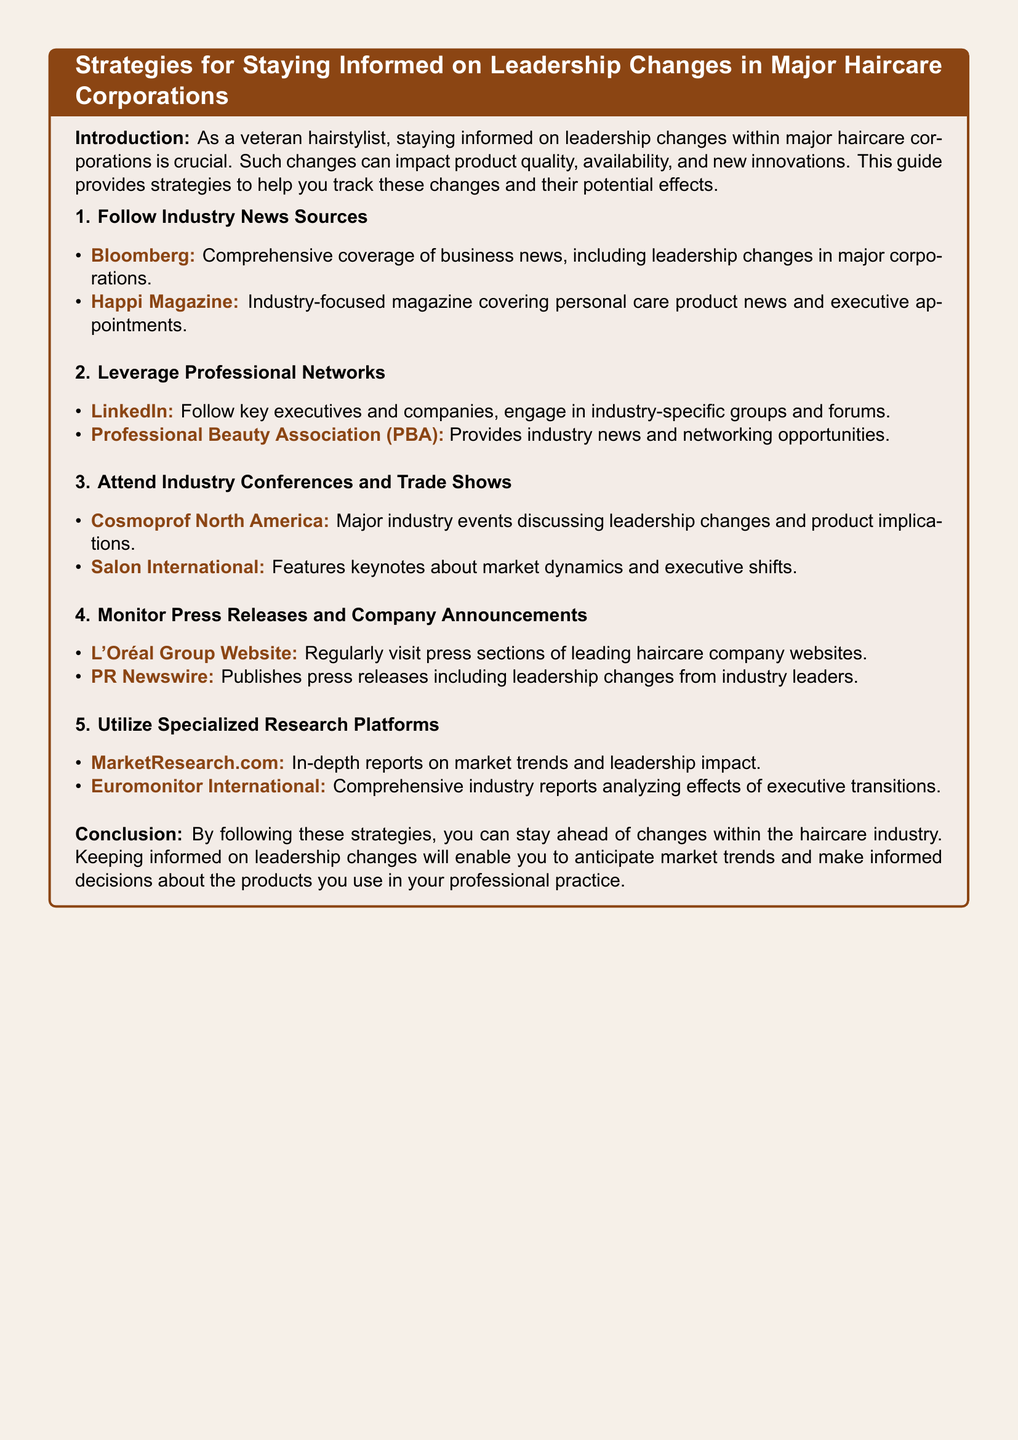What is the document title? The document title is explicitly stated at the top of the rendered output within the title box.
Answer: Strategies for Staying Informed on Leadership Changes in Major Haircare Corporations Who publishes press releases regarding leadership changes? The document mentions PR Newswire as a source for press releases about industry leaders.
Answer: PR Newswire What is the website for L'Oréal Group? The document provides the specific URL for L'Oréal Group under the monitoring section.
Answer: https://www.loreal.com/en/press-and-news/ Name one professional network platform mentioned in the document. The document lists LinkedIn as a platform for leveraging professional networks.
Answer: LinkedIn What type of event is Cosmoprof North America? The document categorizes this event and its purpose clearly in the industry conferences section.
Answer: Major industry event How can specialized research platforms help in the industry? The document suggests these platforms provide reports analyzing the effects of executive transitions, indicating their usefulness.
Answer: Provide in-depth reports on market trends Which magazine focuses on personal care product news? The document specifies Happi Magazine as the industry-focused magazine covering relevant news.
Answer: Happi Magazine What is a crucial reason for staying informed about leadership changes? The document states that leadership changes can impact product quality, availability, and new innovations.
Answer: Product quality and availability What does the document suggest to monitor for updates? The document discusses certain types of publications and sources to regularly check for news on leadership changes.
Answer: Press releases and company announcements 